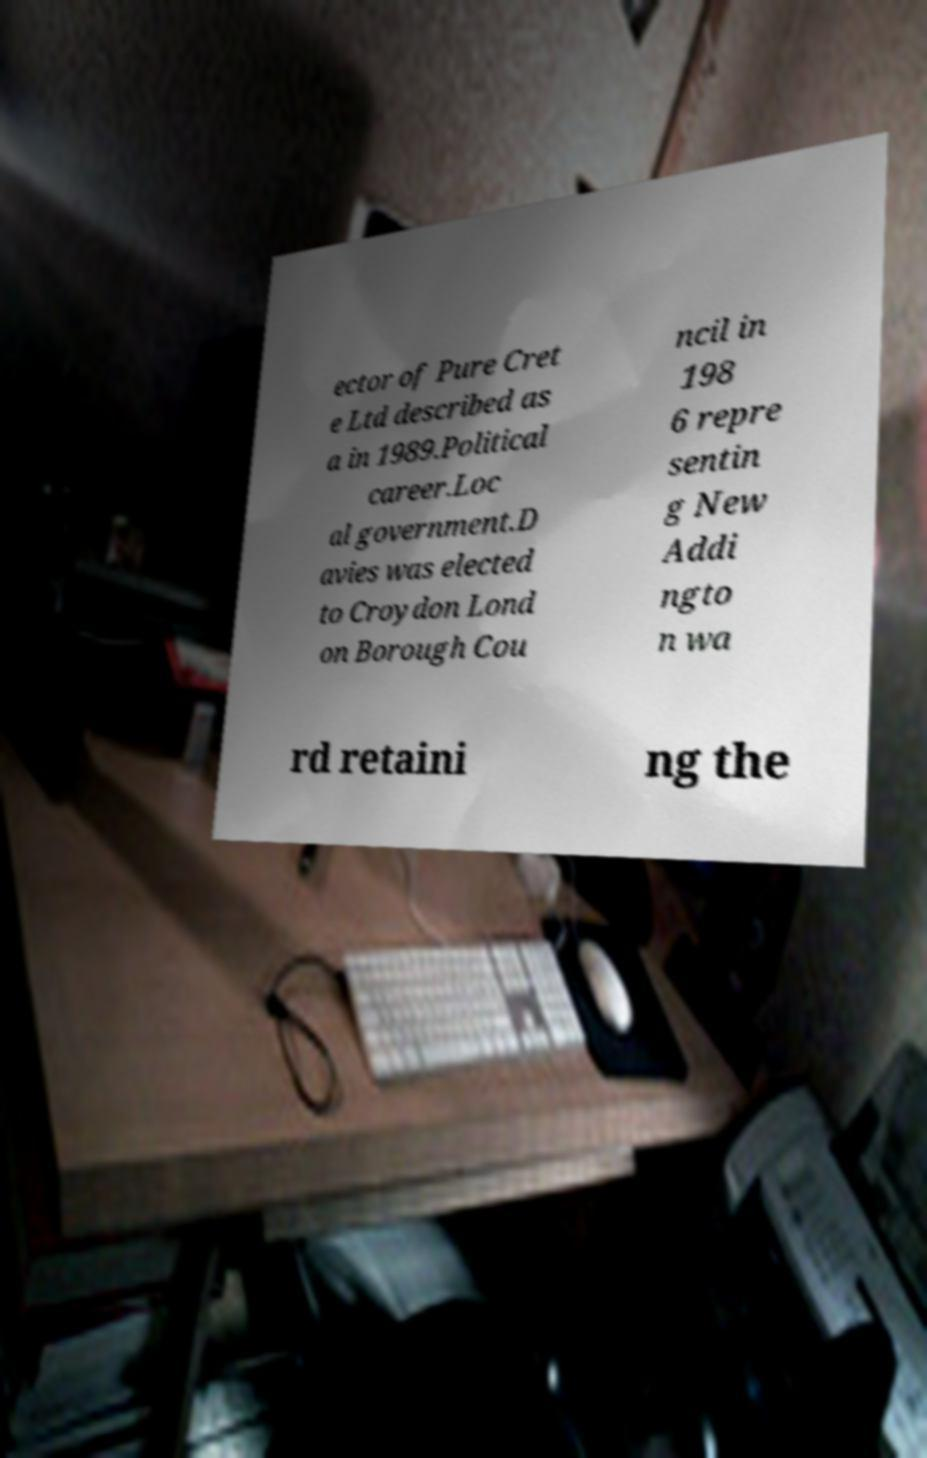Can you read and provide the text displayed in the image?This photo seems to have some interesting text. Can you extract and type it out for me? ector of Pure Cret e Ltd described as a in 1989.Political career.Loc al government.D avies was elected to Croydon Lond on Borough Cou ncil in 198 6 repre sentin g New Addi ngto n wa rd retaini ng the 